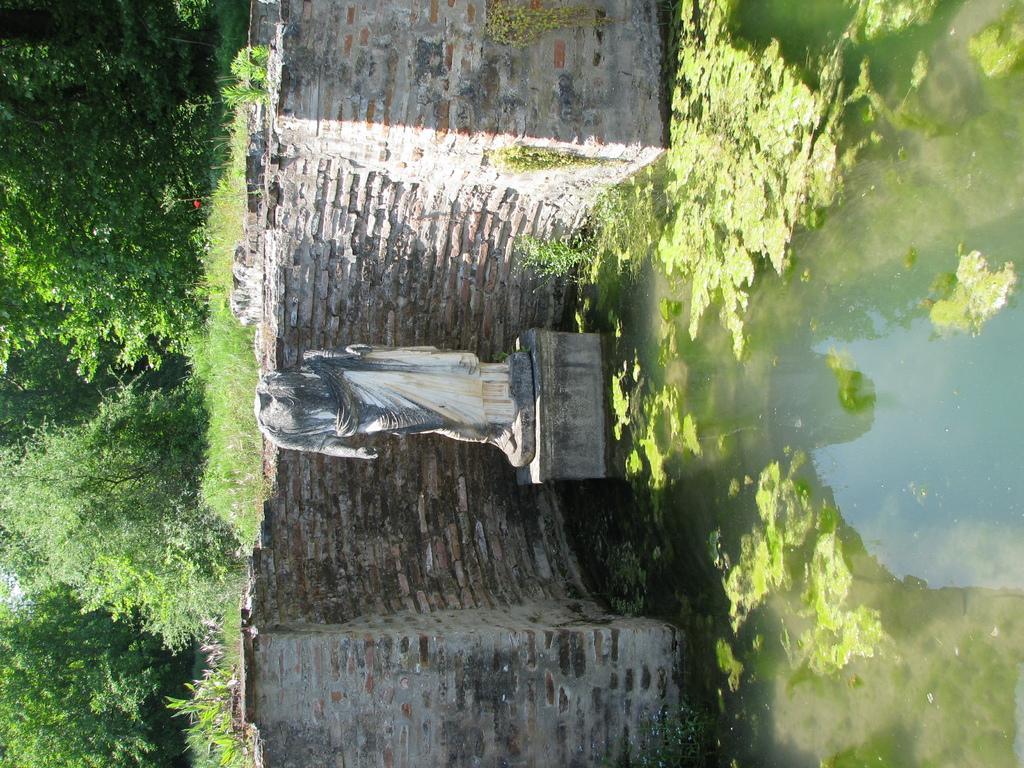Please provide a concise description of this image. In the image we can see the sculpture and the brick wall. Here we can see the water and water algae. We can even see the grass and trees. 